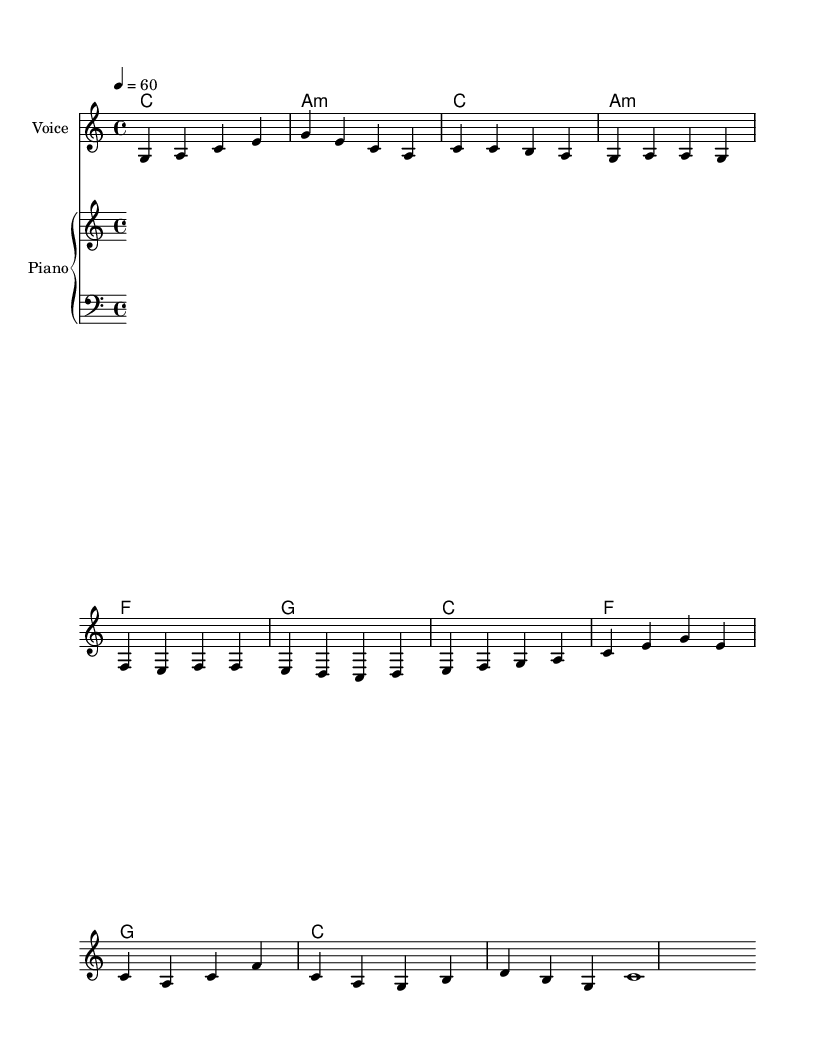What is the key signature of this music? The key signature is C major, which has no sharps or flats indicated in the score. This can be determined by looking at the first section where the global music configuration sets the key signature.
Answer: C major What is the time signature of this piece? The time signature is 4/4, which is indicated in the global configuration of the score. It shows that there are four beats in each measure.
Answer: 4/4 What is the tempo marking for this piece? The tempo marking is 60 beats per minute, which is specified in the global section. This indicates a slow and relaxed pace.
Answer: 60 How many measures are in the verse section? The verse section consists of four measures, as observed from the music notation under the verse part where there are four distinct phrases.
Answer: 4 What is the main theme of the lyrics in the chorus? The lyrics of the chorus emphasize simplicity and minimalism, suggesting that less is more and celebrating the beauty of life stripped of excess. This can be inferred from the lines that repeat these ideas.
Answer: Simplicity What is the harmonic progression for the chorus? The harmonic progression in the chorus follows the chords: C, F, G, C. This can be identified by looking at the chord names indicated directly above the lyrics during the chorus section.
Answer: C, F, G, C What kind of jazz style does this piece represent? This piece represents a stripped-down vocal jazz ballad because it focuses on simple beauty and minimalistic lyrics supported by basic harmonic structures, characteristic of this jazz style.
Answer: Vocal jazz ballad 